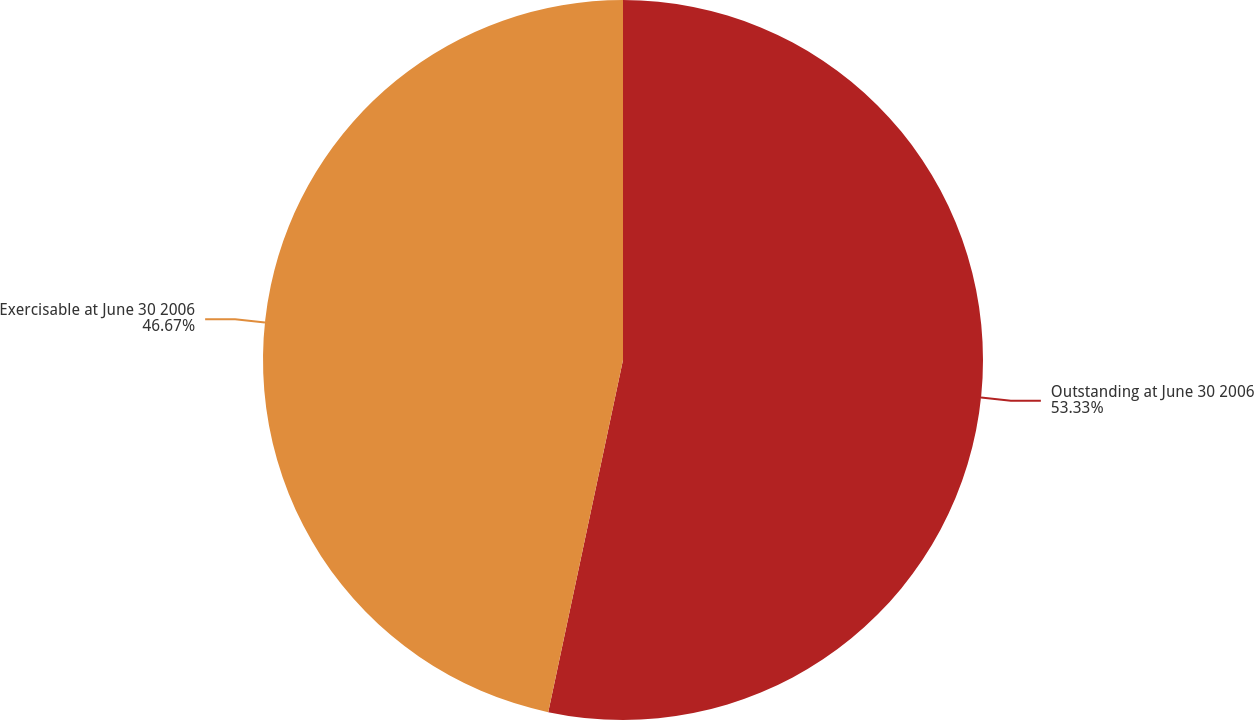Convert chart. <chart><loc_0><loc_0><loc_500><loc_500><pie_chart><fcel>Outstanding at June 30 2006<fcel>Exercisable at June 30 2006<nl><fcel>53.33%<fcel>46.67%<nl></chart> 